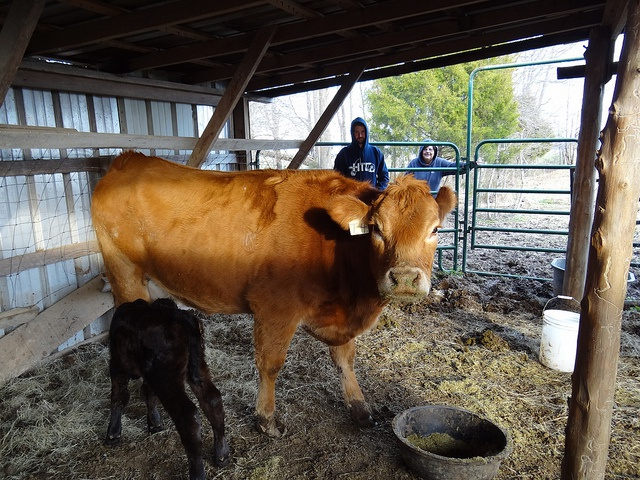Describe the objects in this image and their specific colors. I can see cow in black, brown, maroon, and tan tones, cow in black and gray tones, people in black, navy, blue, and maroon tones, and people in black, navy, gray, and blue tones in this image. 